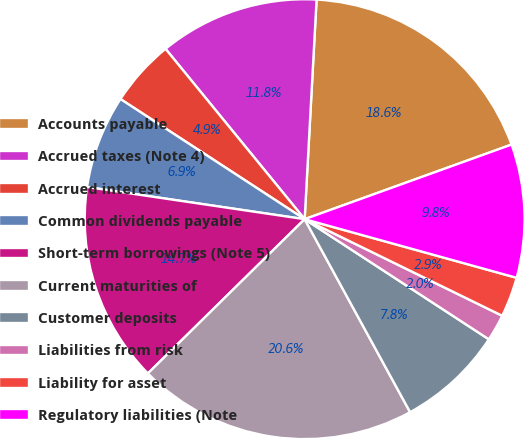Convert chart to OTSL. <chart><loc_0><loc_0><loc_500><loc_500><pie_chart><fcel>Accounts payable<fcel>Accrued taxes (Note 4)<fcel>Accrued interest<fcel>Common dividends payable<fcel>Short-term borrowings (Note 5)<fcel>Current maturities of<fcel>Customer deposits<fcel>Liabilities from risk<fcel>Liability for asset<fcel>Regulatory liabilities (Note<nl><fcel>18.62%<fcel>11.76%<fcel>4.9%<fcel>6.86%<fcel>14.7%<fcel>20.58%<fcel>7.84%<fcel>1.96%<fcel>2.94%<fcel>9.8%<nl></chart> 